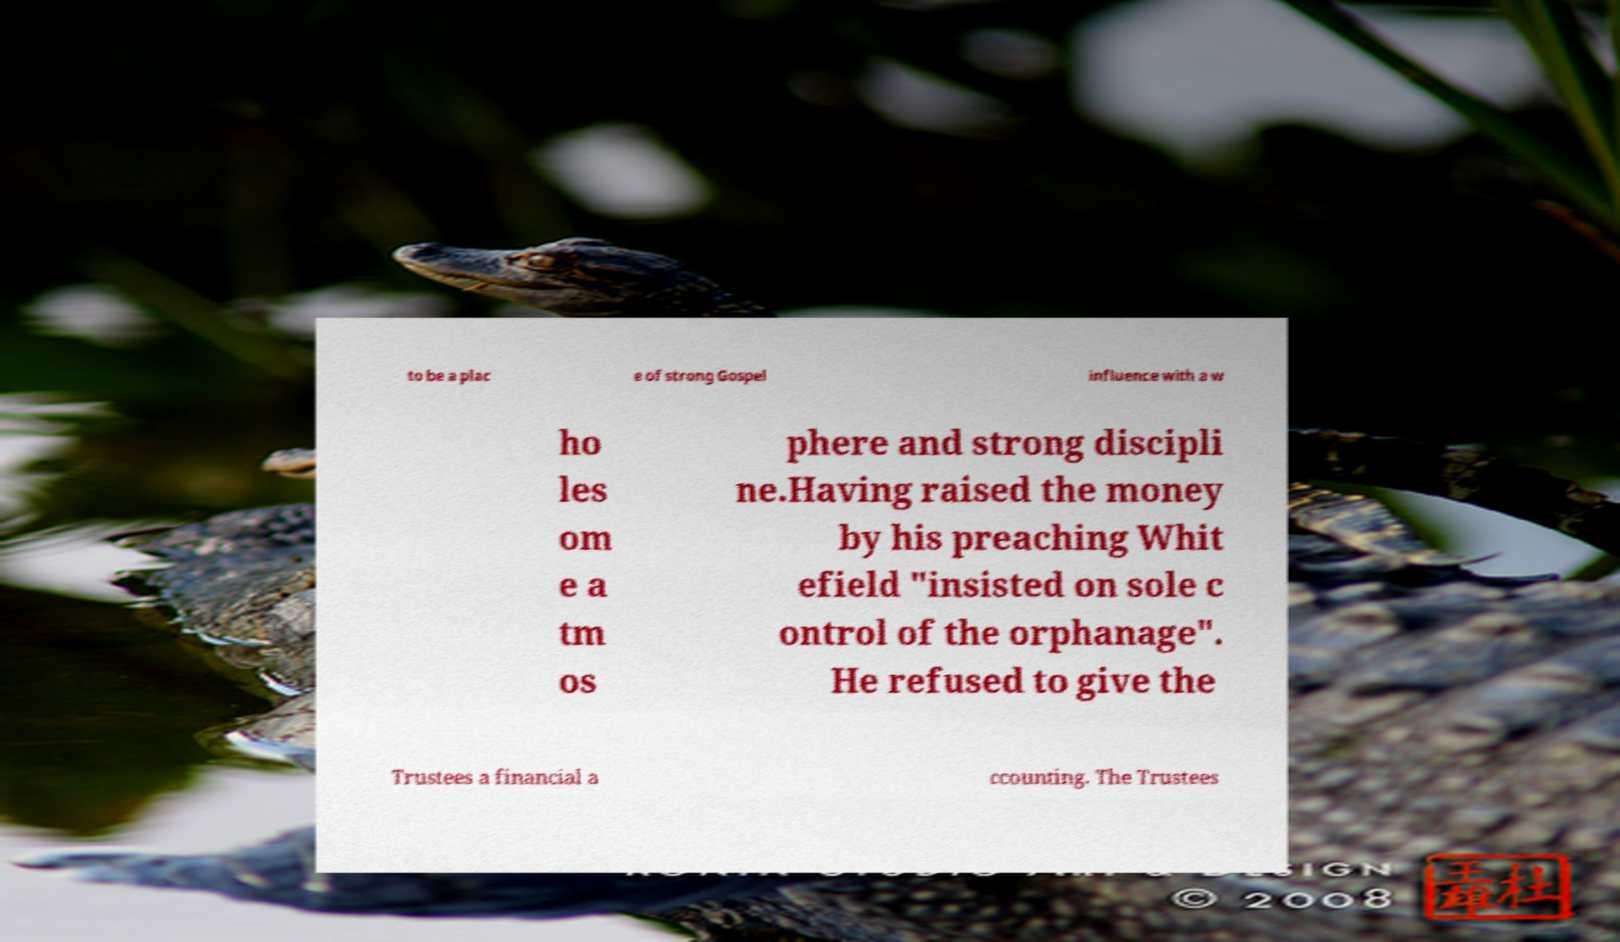Can you accurately transcribe the text from the provided image for me? to be a plac e of strong Gospel influence with a w ho les om e a tm os phere and strong discipli ne.Having raised the money by his preaching Whit efield "insisted on sole c ontrol of the orphanage". He refused to give the Trustees a financial a ccounting. The Trustees 